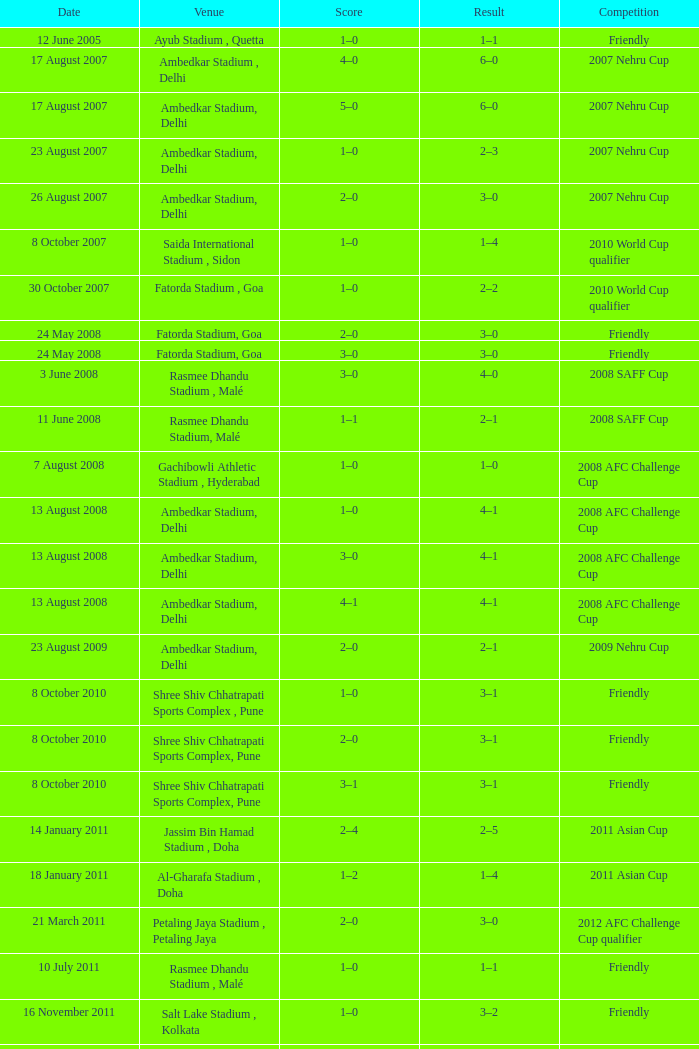Inform me of the score on the 22nd of august, 201 1–0. 